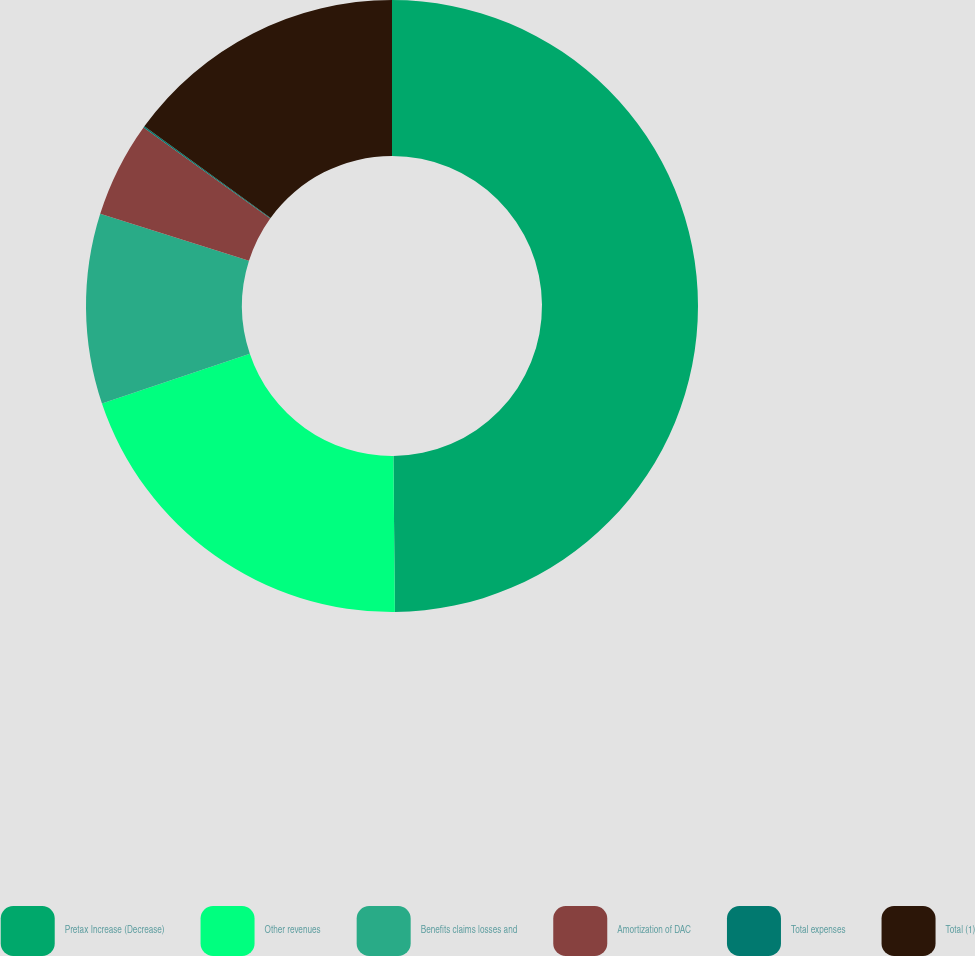Convert chart to OTSL. <chart><loc_0><loc_0><loc_500><loc_500><pie_chart><fcel>Pretax Increase (Decrease)<fcel>Other revenues<fcel>Benefits claims losses and<fcel>Amortization of DAC<fcel>Total expenses<fcel>Total (1)<nl><fcel>49.85%<fcel>19.99%<fcel>10.03%<fcel>5.05%<fcel>0.07%<fcel>15.01%<nl></chart> 